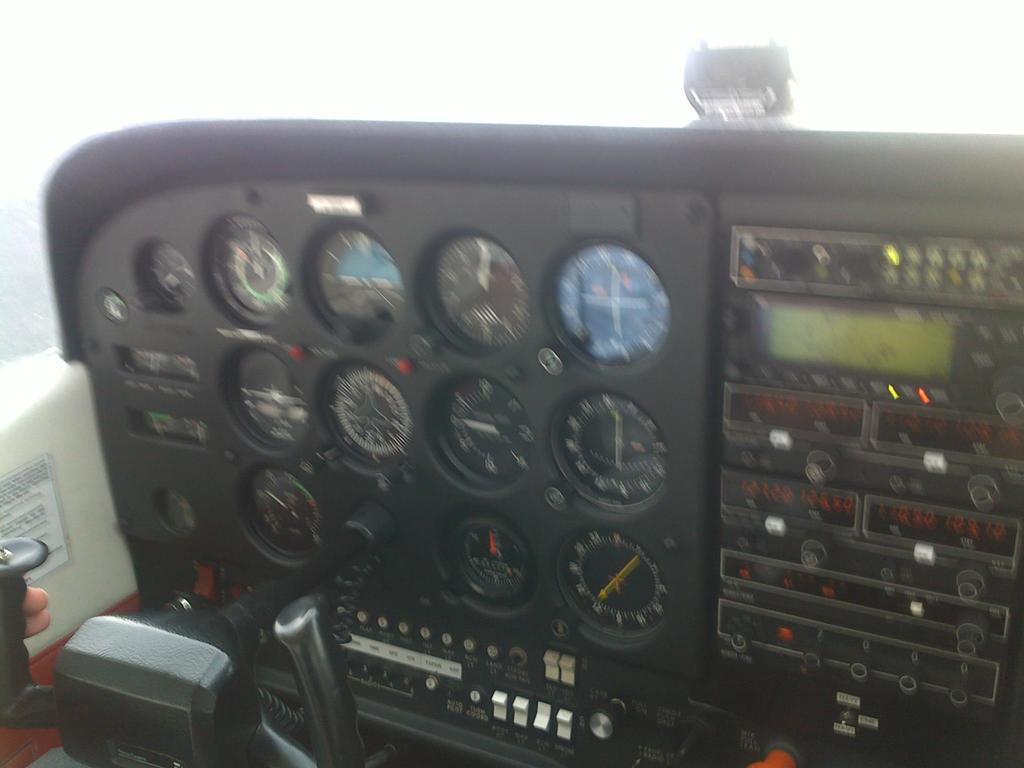What type of equipment can be seen in the image? There are gauges, devices, switches, and a control yoke in the image. What is the setting of the image? The image is from inside an aircraft. Can you describe the person's involvement in the image? The fingers of a person are visible at the bottom left side of the image. What type of suit is the person wearing in the image? There is no suit visible in the image; only the person's fingers are visible at the bottom left side. Can you describe the sink in the image? There is no sink present in the image; it is a cockpit of an aircraft with various equipment and devices. 